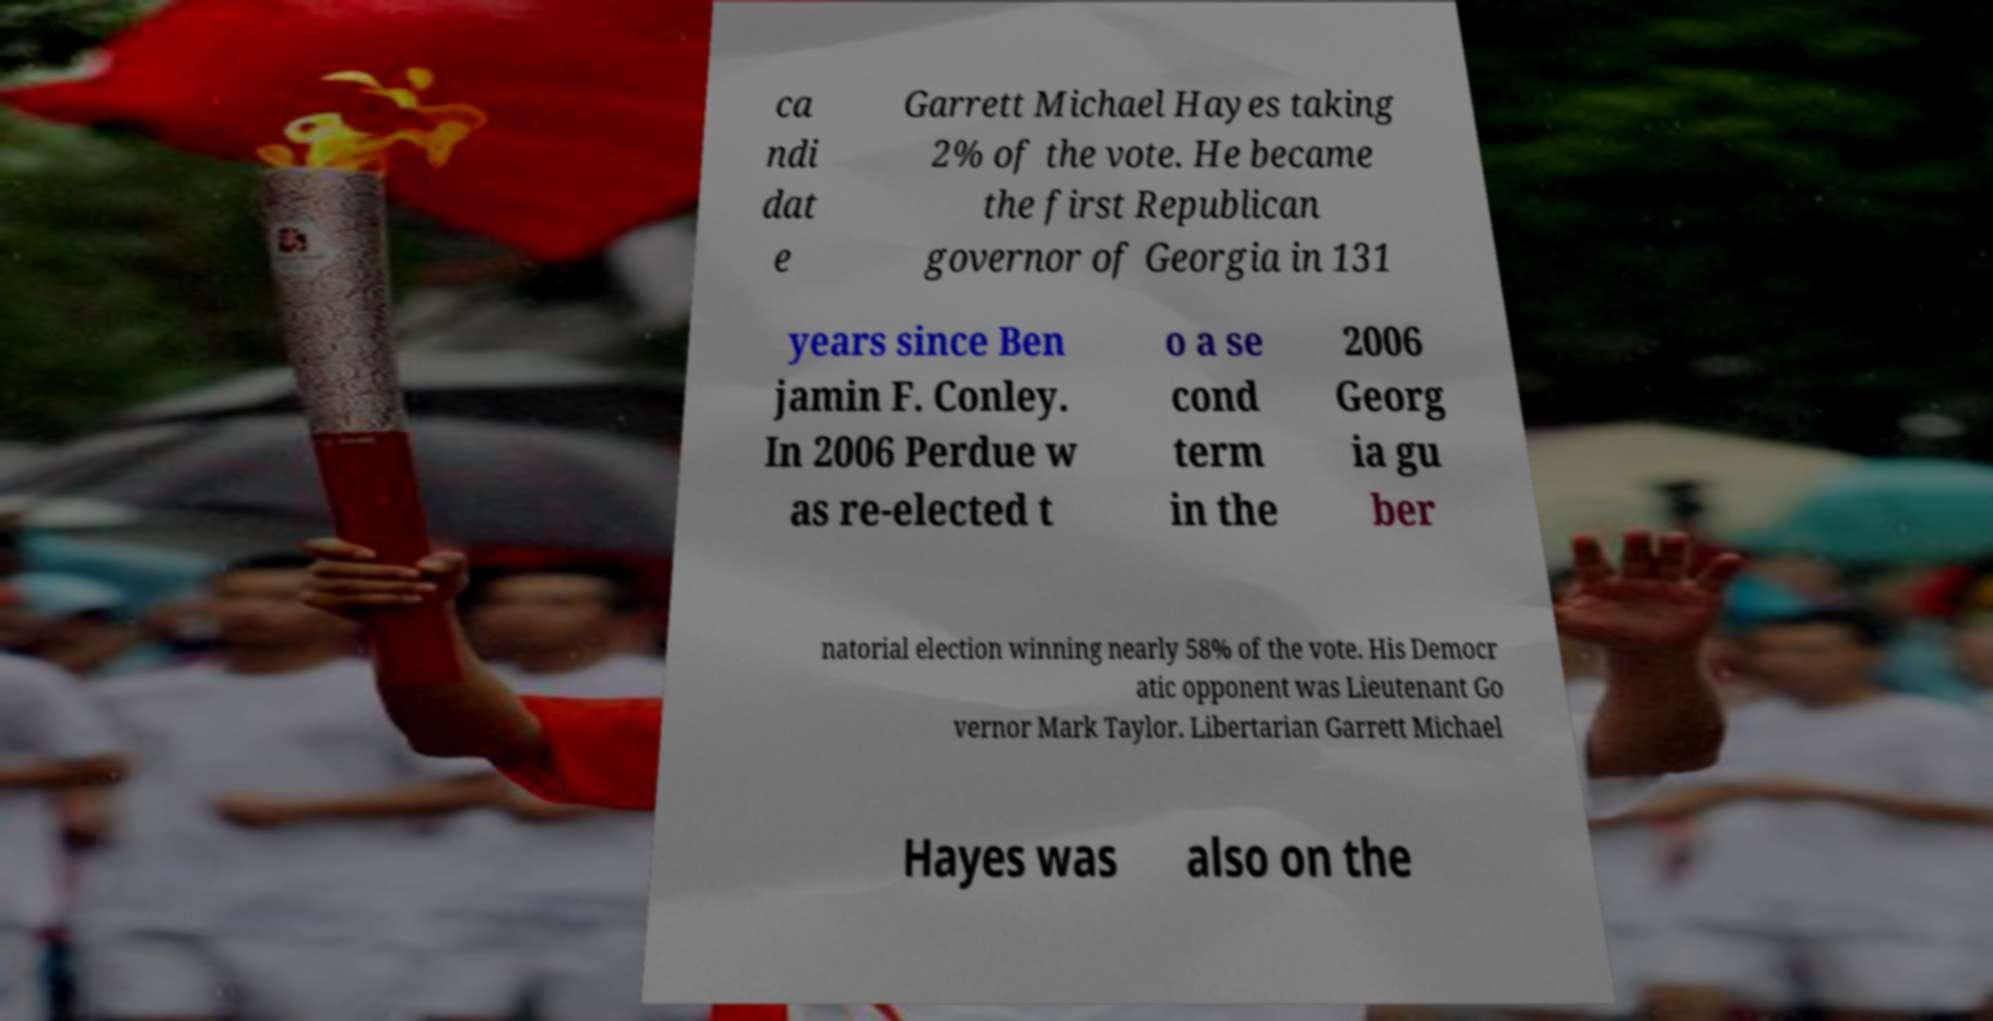What messages or text are displayed in this image? I need them in a readable, typed format. ca ndi dat e Garrett Michael Hayes taking 2% of the vote. He became the first Republican governor of Georgia in 131 years since Ben jamin F. Conley. In 2006 Perdue w as re-elected t o a se cond term in the 2006 Georg ia gu ber natorial election winning nearly 58% of the vote. His Democr atic opponent was Lieutenant Go vernor Mark Taylor. Libertarian Garrett Michael Hayes was also on the 